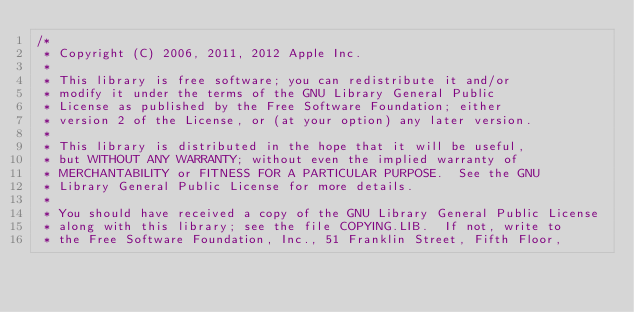<code> <loc_0><loc_0><loc_500><loc_500><_C++_>/*
 * Copyright (C) 2006, 2011, 2012 Apple Inc.
 *
 * This library is free software; you can redistribute it and/or
 * modify it under the terms of the GNU Library General Public
 * License as published by the Free Software Foundation; either
 * version 2 of the License, or (at your option) any later version.
 *
 * This library is distributed in the hope that it will be useful,
 * but WITHOUT ANY WARRANTY; without even the implied warranty of
 * MERCHANTABILITY or FITNESS FOR A PARTICULAR PURPOSE.  See the GNU
 * Library General Public License for more details.
 *
 * You should have received a copy of the GNU Library General Public License
 * along with this library; see the file COPYING.LIB.  If not, write to
 * the Free Software Foundation, Inc., 51 Franklin Street, Fifth Floor,</code> 